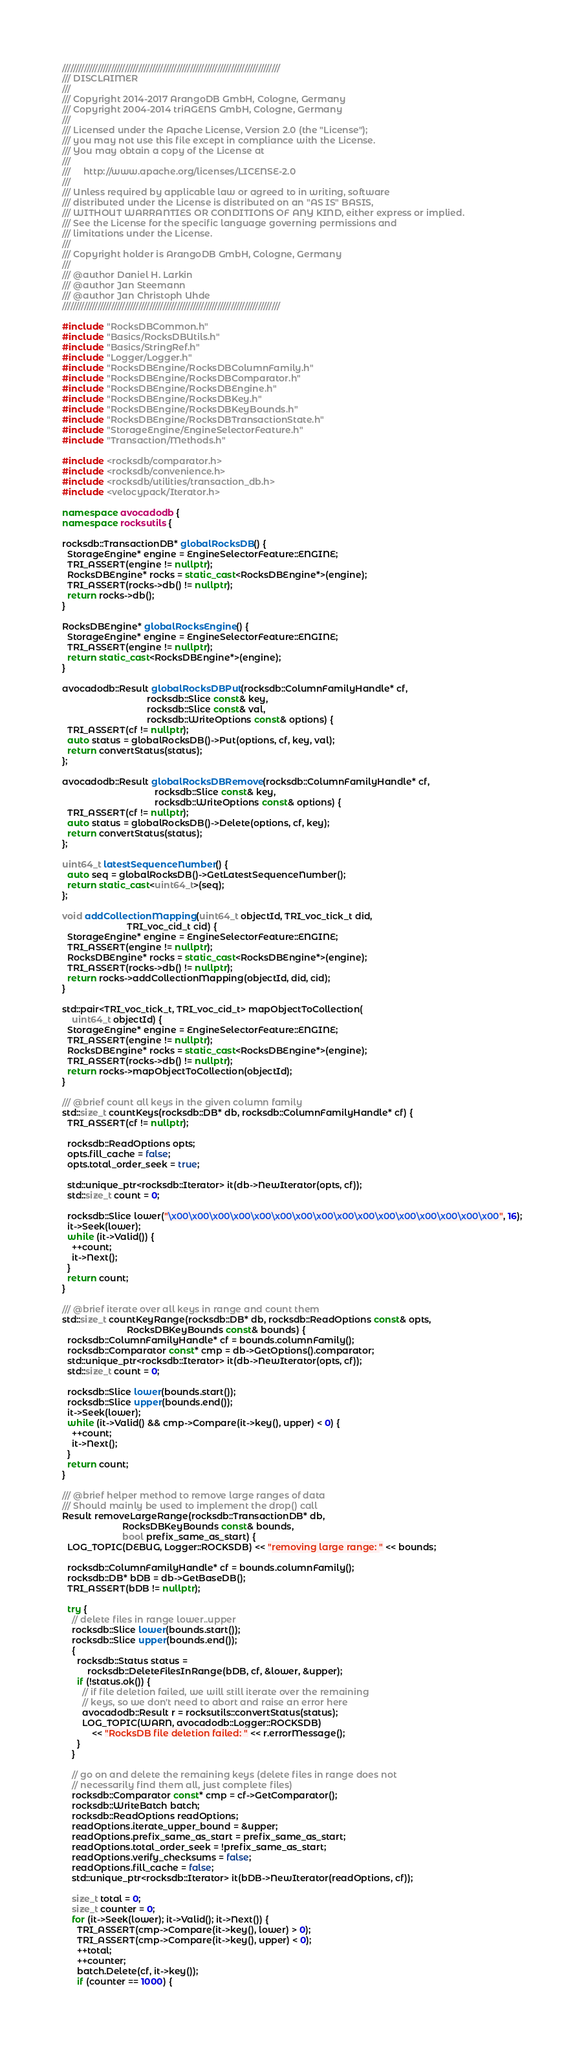<code> <loc_0><loc_0><loc_500><loc_500><_C++_>////////////////////////////////////////////////////////////////////////////////
/// DISCLAIMER
///
/// Copyright 2014-2017 ArangoDB GmbH, Cologne, Germany
/// Copyright 2004-2014 triAGENS GmbH, Cologne, Germany
///
/// Licensed under the Apache License, Version 2.0 (the "License");
/// you may not use this file except in compliance with the License.
/// You may obtain a copy of the License at
///
///     http://www.apache.org/licenses/LICENSE-2.0
///
/// Unless required by applicable law or agreed to in writing, software
/// distributed under the License is distributed on an "AS IS" BASIS,
/// WITHOUT WARRANTIES OR CONDITIONS OF ANY KIND, either express or implied.
/// See the License for the specific language governing permissions and
/// limitations under the License.
///
/// Copyright holder is ArangoDB GmbH, Cologne, Germany
///
/// @author Daniel H. Larkin
/// @author Jan Steemann
/// @author Jan Christoph Uhde
////////////////////////////////////////////////////////////////////////////////

#include "RocksDBCommon.h"
#include "Basics/RocksDBUtils.h"
#include "Basics/StringRef.h"
#include "Logger/Logger.h"
#include "RocksDBEngine/RocksDBColumnFamily.h"
#include "RocksDBEngine/RocksDBComparator.h"
#include "RocksDBEngine/RocksDBEngine.h"
#include "RocksDBEngine/RocksDBKey.h"
#include "RocksDBEngine/RocksDBKeyBounds.h"
#include "RocksDBEngine/RocksDBTransactionState.h"
#include "StorageEngine/EngineSelectorFeature.h"
#include "Transaction/Methods.h"

#include <rocksdb/comparator.h>
#include <rocksdb/convenience.h>
#include <rocksdb/utilities/transaction_db.h>
#include <velocypack/Iterator.h>

namespace avocadodb {
namespace rocksutils {

rocksdb::TransactionDB* globalRocksDB() {
  StorageEngine* engine = EngineSelectorFeature::ENGINE;
  TRI_ASSERT(engine != nullptr);
  RocksDBEngine* rocks = static_cast<RocksDBEngine*>(engine);
  TRI_ASSERT(rocks->db() != nullptr);
  return rocks->db();
}

RocksDBEngine* globalRocksEngine() {
  StorageEngine* engine = EngineSelectorFeature::ENGINE;
  TRI_ASSERT(engine != nullptr);
  return static_cast<RocksDBEngine*>(engine);
}

avocadodb::Result globalRocksDBPut(rocksdb::ColumnFamilyHandle* cf,
                                  rocksdb::Slice const& key,
                                  rocksdb::Slice const& val,
                                  rocksdb::WriteOptions const& options) {
  TRI_ASSERT(cf != nullptr);
  auto status = globalRocksDB()->Put(options, cf, key, val);
  return convertStatus(status);
};

avocadodb::Result globalRocksDBRemove(rocksdb::ColumnFamilyHandle* cf,
                                     rocksdb::Slice const& key,
                                     rocksdb::WriteOptions const& options) {
  TRI_ASSERT(cf != nullptr);
  auto status = globalRocksDB()->Delete(options, cf, key);
  return convertStatus(status);
};

uint64_t latestSequenceNumber() {
  auto seq = globalRocksDB()->GetLatestSequenceNumber();
  return static_cast<uint64_t>(seq);
};

void addCollectionMapping(uint64_t objectId, TRI_voc_tick_t did,
                          TRI_voc_cid_t cid) {
  StorageEngine* engine = EngineSelectorFeature::ENGINE;
  TRI_ASSERT(engine != nullptr);
  RocksDBEngine* rocks = static_cast<RocksDBEngine*>(engine);
  TRI_ASSERT(rocks->db() != nullptr);
  return rocks->addCollectionMapping(objectId, did, cid);
}

std::pair<TRI_voc_tick_t, TRI_voc_cid_t> mapObjectToCollection(
    uint64_t objectId) {
  StorageEngine* engine = EngineSelectorFeature::ENGINE;
  TRI_ASSERT(engine != nullptr);
  RocksDBEngine* rocks = static_cast<RocksDBEngine*>(engine);
  TRI_ASSERT(rocks->db() != nullptr);
  return rocks->mapObjectToCollection(objectId);
}

/// @brief count all keys in the given column family
std::size_t countKeys(rocksdb::DB* db, rocksdb::ColumnFamilyHandle* cf) {
  TRI_ASSERT(cf != nullptr);

  rocksdb::ReadOptions opts;
  opts.fill_cache = false;
  opts.total_order_seek = true;

  std::unique_ptr<rocksdb::Iterator> it(db->NewIterator(opts, cf));
  std::size_t count = 0;

  rocksdb::Slice lower("\x00\x00\x00\x00\x00\x00\x00\x00\x00\x00\x00\x00\x00\x00\x00\x00", 16);
  it->Seek(lower);
  while (it->Valid()) {
    ++count;
    it->Next();
  }
  return count;
}

/// @brief iterate over all keys in range and count them
std::size_t countKeyRange(rocksdb::DB* db, rocksdb::ReadOptions const& opts,
                          RocksDBKeyBounds const& bounds) {
  rocksdb::ColumnFamilyHandle* cf = bounds.columnFamily();
  rocksdb::Comparator const* cmp = db->GetOptions().comparator;
  std::unique_ptr<rocksdb::Iterator> it(db->NewIterator(opts, cf));
  std::size_t count = 0;

  rocksdb::Slice lower(bounds.start());
  rocksdb::Slice upper(bounds.end());
  it->Seek(lower);
  while (it->Valid() && cmp->Compare(it->key(), upper) < 0) {
    ++count;
    it->Next();
  }
  return count;
}

/// @brief helper method to remove large ranges of data
/// Should mainly be used to implement the drop() call
Result removeLargeRange(rocksdb::TransactionDB* db,
                        RocksDBKeyBounds const& bounds,
                        bool prefix_same_as_start) {
  LOG_TOPIC(DEBUG, Logger::ROCKSDB) << "removing large range: " << bounds;
  
  rocksdb::ColumnFamilyHandle* cf = bounds.columnFamily();
  rocksdb::DB* bDB = db->GetBaseDB();
  TRI_ASSERT(bDB != nullptr);

  try {
    // delete files in range lower..upper
    rocksdb::Slice lower(bounds.start());
    rocksdb::Slice upper(bounds.end());
    {
      rocksdb::Status status =
          rocksdb::DeleteFilesInRange(bDB, cf, &lower, &upper);
      if (!status.ok()) {
        // if file deletion failed, we will still iterate over the remaining
        // keys, so we don't need to abort and raise an error here
        avocadodb::Result r = rocksutils::convertStatus(status);
        LOG_TOPIC(WARN, avocadodb::Logger::ROCKSDB)
            << "RocksDB file deletion failed: " << r.errorMessage();
      }
    }
    
    // go on and delete the remaining keys (delete files in range does not
    // necessarily find them all, just complete files)
    rocksdb::Comparator const* cmp = cf->GetComparator();
    rocksdb::WriteBatch batch;
    rocksdb::ReadOptions readOptions;
    readOptions.iterate_upper_bound = &upper;
    readOptions.prefix_same_as_start = prefix_same_as_start;
    readOptions.total_order_seek = !prefix_same_as_start;
    readOptions.verify_checksums = false;
    readOptions.fill_cache = false;
    std::unique_ptr<rocksdb::Iterator> it(bDB->NewIterator(readOptions, cf));

    size_t total = 0;
    size_t counter = 0;
    for (it->Seek(lower); it->Valid(); it->Next()) {
      TRI_ASSERT(cmp->Compare(it->key(), lower) > 0);
      TRI_ASSERT(cmp->Compare(it->key(), upper) < 0);
      ++total;
      ++counter;
      batch.Delete(cf, it->key());
      if (counter == 1000) {</code> 